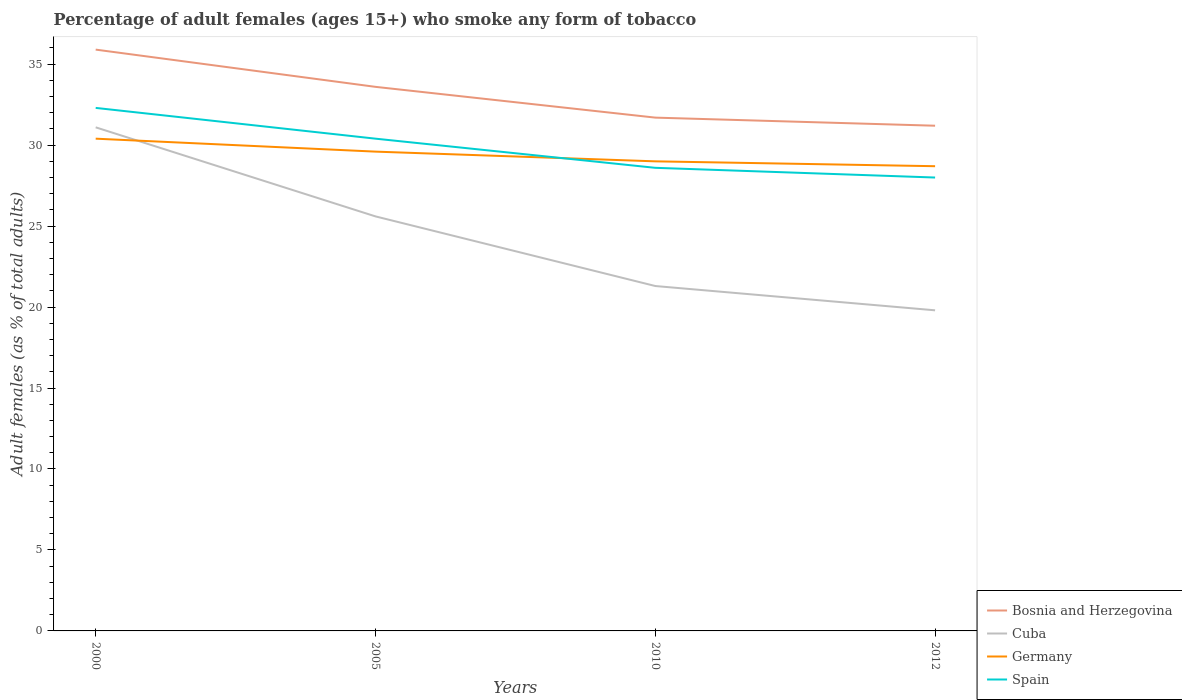How many different coloured lines are there?
Your response must be concise. 4. Does the line corresponding to Cuba intersect with the line corresponding to Germany?
Your response must be concise. Yes. Is the number of lines equal to the number of legend labels?
Provide a short and direct response. Yes. Across all years, what is the maximum percentage of adult females who smoke in Bosnia and Herzegovina?
Offer a terse response. 31.2. In which year was the percentage of adult females who smoke in Spain maximum?
Your response must be concise. 2012. What is the total percentage of adult females who smoke in Bosnia and Herzegovina in the graph?
Keep it short and to the point. 4.2. What is the difference between the highest and the second highest percentage of adult females who smoke in Germany?
Provide a short and direct response. 1.7. Is the percentage of adult females who smoke in Spain strictly greater than the percentage of adult females who smoke in Germany over the years?
Your response must be concise. No. How many lines are there?
Keep it short and to the point. 4. What is the difference between two consecutive major ticks on the Y-axis?
Your answer should be compact. 5. Does the graph contain any zero values?
Provide a succinct answer. No. Does the graph contain grids?
Your response must be concise. No. Where does the legend appear in the graph?
Keep it short and to the point. Bottom right. How many legend labels are there?
Your response must be concise. 4. How are the legend labels stacked?
Keep it short and to the point. Vertical. What is the title of the graph?
Your answer should be compact. Percentage of adult females (ages 15+) who smoke any form of tobacco. What is the label or title of the X-axis?
Give a very brief answer. Years. What is the label or title of the Y-axis?
Keep it short and to the point. Adult females (as % of total adults). What is the Adult females (as % of total adults) of Bosnia and Herzegovina in 2000?
Keep it short and to the point. 35.9. What is the Adult females (as % of total adults) in Cuba in 2000?
Provide a short and direct response. 31.1. What is the Adult females (as % of total adults) in Germany in 2000?
Keep it short and to the point. 30.4. What is the Adult females (as % of total adults) in Spain in 2000?
Your answer should be very brief. 32.3. What is the Adult females (as % of total adults) in Bosnia and Herzegovina in 2005?
Your answer should be compact. 33.6. What is the Adult females (as % of total adults) in Cuba in 2005?
Make the answer very short. 25.6. What is the Adult females (as % of total adults) of Germany in 2005?
Make the answer very short. 29.6. What is the Adult females (as % of total adults) of Spain in 2005?
Ensure brevity in your answer.  30.4. What is the Adult females (as % of total adults) in Bosnia and Herzegovina in 2010?
Provide a short and direct response. 31.7. What is the Adult females (as % of total adults) of Cuba in 2010?
Provide a succinct answer. 21.3. What is the Adult females (as % of total adults) of Spain in 2010?
Provide a succinct answer. 28.6. What is the Adult females (as % of total adults) in Bosnia and Herzegovina in 2012?
Offer a very short reply. 31.2. What is the Adult females (as % of total adults) in Cuba in 2012?
Your response must be concise. 19.8. What is the Adult females (as % of total adults) of Germany in 2012?
Give a very brief answer. 28.7. Across all years, what is the maximum Adult females (as % of total adults) of Bosnia and Herzegovina?
Keep it short and to the point. 35.9. Across all years, what is the maximum Adult females (as % of total adults) in Cuba?
Your answer should be compact. 31.1. Across all years, what is the maximum Adult females (as % of total adults) of Germany?
Ensure brevity in your answer.  30.4. Across all years, what is the maximum Adult females (as % of total adults) in Spain?
Your answer should be compact. 32.3. Across all years, what is the minimum Adult females (as % of total adults) in Bosnia and Herzegovina?
Provide a short and direct response. 31.2. Across all years, what is the minimum Adult females (as % of total adults) of Cuba?
Provide a short and direct response. 19.8. Across all years, what is the minimum Adult females (as % of total adults) in Germany?
Keep it short and to the point. 28.7. Across all years, what is the minimum Adult females (as % of total adults) of Spain?
Ensure brevity in your answer.  28. What is the total Adult females (as % of total adults) of Bosnia and Herzegovina in the graph?
Provide a short and direct response. 132.4. What is the total Adult females (as % of total adults) of Cuba in the graph?
Provide a short and direct response. 97.8. What is the total Adult females (as % of total adults) in Germany in the graph?
Give a very brief answer. 117.7. What is the total Adult females (as % of total adults) of Spain in the graph?
Your answer should be very brief. 119.3. What is the difference between the Adult females (as % of total adults) in Germany in 2000 and that in 2005?
Offer a very short reply. 0.8. What is the difference between the Adult females (as % of total adults) of Bosnia and Herzegovina in 2000 and that in 2010?
Give a very brief answer. 4.2. What is the difference between the Adult females (as % of total adults) of Cuba in 2000 and that in 2012?
Provide a succinct answer. 11.3. What is the difference between the Adult females (as % of total adults) in Germany in 2005 and that in 2010?
Provide a short and direct response. 0.6. What is the difference between the Adult females (as % of total adults) in Germany in 2005 and that in 2012?
Give a very brief answer. 0.9. What is the difference between the Adult females (as % of total adults) in Cuba in 2010 and that in 2012?
Provide a short and direct response. 1.5. What is the difference between the Adult females (as % of total adults) in Germany in 2010 and that in 2012?
Ensure brevity in your answer.  0.3. What is the difference between the Adult females (as % of total adults) of Cuba in 2000 and the Adult females (as % of total adults) of Germany in 2005?
Provide a succinct answer. 1.5. What is the difference between the Adult females (as % of total adults) in Cuba in 2000 and the Adult females (as % of total adults) in Spain in 2005?
Give a very brief answer. 0.7. What is the difference between the Adult females (as % of total adults) of Bosnia and Herzegovina in 2000 and the Adult females (as % of total adults) of Cuba in 2010?
Ensure brevity in your answer.  14.6. What is the difference between the Adult females (as % of total adults) of Germany in 2000 and the Adult females (as % of total adults) of Spain in 2010?
Keep it short and to the point. 1.8. What is the difference between the Adult females (as % of total adults) of Bosnia and Herzegovina in 2000 and the Adult females (as % of total adults) of Germany in 2012?
Provide a short and direct response. 7.2. What is the difference between the Adult females (as % of total adults) of Bosnia and Herzegovina in 2000 and the Adult females (as % of total adults) of Spain in 2012?
Offer a terse response. 7.9. What is the difference between the Adult females (as % of total adults) of Cuba in 2000 and the Adult females (as % of total adults) of Germany in 2012?
Offer a very short reply. 2.4. What is the difference between the Adult females (as % of total adults) of Germany in 2000 and the Adult females (as % of total adults) of Spain in 2012?
Provide a short and direct response. 2.4. What is the difference between the Adult females (as % of total adults) of Bosnia and Herzegovina in 2005 and the Adult females (as % of total adults) of Cuba in 2010?
Provide a succinct answer. 12.3. What is the difference between the Adult females (as % of total adults) of Germany in 2005 and the Adult females (as % of total adults) of Spain in 2010?
Offer a terse response. 1. What is the difference between the Adult females (as % of total adults) of Bosnia and Herzegovina in 2005 and the Adult females (as % of total adults) of Cuba in 2012?
Give a very brief answer. 13.8. What is the difference between the Adult females (as % of total adults) of Bosnia and Herzegovina in 2005 and the Adult females (as % of total adults) of Germany in 2012?
Make the answer very short. 4.9. What is the difference between the Adult females (as % of total adults) in Cuba in 2005 and the Adult females (as % of total adults) in Spain in 2012?
Offer a very short reply. -2.4. What is the difference between the Adult females (as % of total adults) of Germany in 2005 and the Adult females (as % of total adults) of Spain in 2012?
Provide a succinct answer. 1.6. What is the difference between the Adult females (as % of total adults) in Bosnia and Herzegovina in 2010 and the Adult females (as % of total adults) in Cuba in 2012?
Your answer should be very brief. 11.9. What is the difference between the Adult females (as % of total adults) in Bosnia and Herzegovina in 2010 and the Adult females (as % of total adults) in Germany in 2012?
Provide a short and direct response. 3. What is the difference between the Adult females (as % of total adults) of Bosnia and Herzegovina in 2010 and the Adult females (as % of total adults) of Spain in 2012?
Ensure brevity in your answer.  3.7. What is the difference between the Adult females (as % of total adults) of Cuba in 2010 and the Adult females (as % of total adults) of Spain in 2012?
Offer a terse response. -6.7. What is the difference between the Adult females (as % of total adults) of Germany in 2010 and the Adult females (as % of total adults) of Spain in 2012?
Your response must be concise. 1. What is the average Adult females (as % of total adults) in Bosnia and Herzegovina per year?
Provide a short and direct response. 33.1. What is the average Adult females (as % of total adults) in Cuba per year?
Give a very brief answer. 24.45. What is the average Adult females (as % of total adults) of Germany per year?
Provide a short and direct response. 29.43. What is the average Adult females (as % of total adults) in Spain per year?
Offer a very short reply. 29.82. In the year 2000, what is the difference between the Adult females (as % of total adults) in Bosnia and Herzegovina and Adult females (as % of total adults) in Cuba?
Offer a terse response. 4.8. In the year 2000, what is the difference between the Adult females (as % of total adults) in Cuba and Adult females (as % of total adults) in Germany?
Make the answer very short. 0.7. In the year 2000, what is the difference between the Adult females (as % of total adults) of Cuba and Adult females (as % of total adults) of Spain?
Your answer should be compact. -1.2. In the year 2000, what is the difference between the Adult females (as % of total adults) of Germany and Adult females (as % of total adults) of Spain?
Keep it short and to the point. -1.9. In the year 2005, what is the difference between the Adult females (as % of total adults) of Germany and Adult females (as % of total adults) of Spain?
Give a very brief answer. -0.8. In the year 2010, what is the difference between the Adult females (as % of total adults) in Bosnia and Herzegovina and Adult females (as % of total adults) in Cuba?
Make the answer very short. 10.4. In the year 2010, what is the difference between the Adult females (as % of total adults) in Bosnia and Herzegovina and Adult females (as % of total adults) in Germany?
Your answer should be compact. 2.7. In the year 2010, what is the difference between the Adult females (as % of total adults) in Bosnia and Herzegovina and Adult females (as % of total adults) in Spain?
Provide a succinct answer. 3.1. In the year 2010, what is the difference between the Adult females (as % of total adults) of Cuba and Adult females (as % of total adults) of Spain?
Give a very brief answer. -7.3. In the year 2010, what is the difference between the Adult females (as % of total adults) of Germany and Adult females (as % of total adults) of Spain?
Provide a short and direct response. 0.4. In the year 2012, what is the difference between the Adult females (as % of total adults) in Bosnia and Herzegovina and Adult females (as % of total adults) in Cuba?
Your answer should be compact. 11.4. In the year 2012, what is the difference between the Adult females (as % of total adults) of Bosnia and Herzegovina and Adult females (as % of total adults) of Germany?
Ensure brevity in your answer.  2.5. In the year 2012, what is the difference between the Adult females (as % of total adults) in Bosnia and Herzegovina and Adult females (as % of total adults) in Spain?
Ensure brevity in your answer.  3.2. In the year 2012, what is the difference between the Adult females (as % of total adults) in Germany and Adult females (as % of total adults) in Spain?
Keep it short and to the point. 0.7. What is the ratio of the Adult females (as % of total adults) in Bosnia and Herzegovina in 2000 to that in 2005?
Your answer should be compact. 1.07. What is the ratio of the Adult females (as % of total adults) in Cuba in 2000 to that in 2005?
Offer a terse response. 1.21. What is the ratio of the Adult females (as % of total adults) of Germany in 2000 to that in 2005?
Give a very brief answer. 1.03. What is the ratio of the Adult females (as % of total adults) of Spain in 2000 to that in 2005?
Provide a short and direct response. 1.06. What is the ratio of the Adult females (as % of total adults) in Bosnia and Herzegovina in 2000 to that in 2010?
Offer a terse response. 1.13. What is the ratio of the Adult females (as % of total adults) of Cuba in 2000 to that in 2010?
Your response must be concise. 1.46. What is the ratio of the Adult females (as % of total adults) of Germany in 2000 to that in 2010?
Give a very brief answer. 1.05. What is the ratio of the Adult females (as % of total adults) in Spain in 2000 to that in 2010?
Make the answer very short. 1.13. What is the ratio of the Adult females (as % of total adults) of Bosnia and Herzegovina in 2000 to that in 2012?
Keep it short and to the point. 1.15. What is the ratio of the Adult females (as % of total adults) of Cuba in 2000 to that in 2012?
Your answer should be compact. 1.57. What is the ratio of the Adult females (as % of total adults) in Germany in 2000 to that in 2012?
Offer a terse response. 1.06. What is the ratio of the Adult females (as % of total adults) in Spain in 2000 to that in 2012?
Offer a terse response. 1.15. What is the ratio of the Adult females (as % of total adults) in Bosnia and Herzegovina in 2005 to that in 2010?
Provide a succinct answer. 1.06. What is the ratio of the Adult females (as % of total adults) of Cuba in 2005 to that in 2010?
Provide a short and direct response. 1.2. What is the ratio of the Adult females (as % of total adults) in Germany in 2005 to that in 2010?
Give a very brief answer. 1.02. What is the ratio of the Adult females (as % of total adults) in Spain in 2005 to that in 2010?
Keep it short and to the point. 1.06. What is the ratio of the Adult females (as % of total adults) of Bosnia and Herzegovina in 2005 to that in 2012?
Your response must be concise. 1.08. What is the ratio of the Adult females (as % of total adults) in Cuba in 2005 to that in 2012?
Ensure brevity in your answer.  1.29. What is the ratio of the Adult females (as % of total adults) in Germany in 2005 to that in 2012?
Provide a short and direct response. 1.03. What is the ratio of the Adult females (as % of total adults) in Spain in 2005 to that in 2012?
Make the answer very short. 1.09. What is the ratio of the Adult females (as % of total adults) of Cuba in 2010 to that in 2012?
Your response must be concise. 1.08. What is the ratio of the Adult females (as % of total adults) of Germany in 2010 to that in 2012?
Your answer should be compact. 1.01. What is the ratio of the Adult females (as % of total adults) of Spain in 2010 to that in 2012?
Offer a terse response. 1.02. What is the difference between the highest and the second highest Adult females (as % of total adults) of Germany?
Your response must be concise. 0.8. What is the difference between the highest and the lowest Adult females (as % of total adults) in Bosnia and Herzegovina?
Your response must be concise. 4.7. What is the difference between the highest and the lowest Adult females (as % of total adults) of Cuba?
Make the answer very short. 11.3. What is the difference between the highest and the lowest Adult females (as % of total adults) in Germany?
Provide a succinct answer. 1.7. What is the difference between the highest and the lowest Adult females (as % of total adults) in Spain?
Make the answer very short. 4.3. 